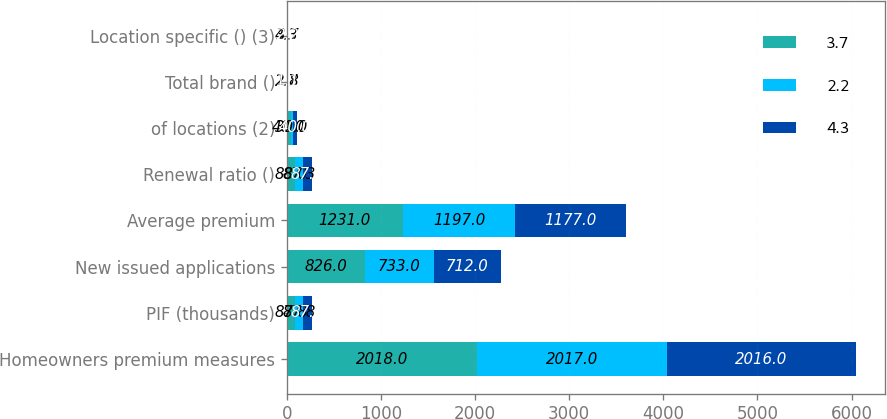Convert chart to OTSL. <chart><loc_0><loc_0><loc_500><loc_500><stacked_bar_chart><ecel><fcel>Homeowners premium measures<fcel>PIF (thousands)<fcel>New issued applications<fcel>Average premium<fcel>Renewal ratio ()<fcel>of locations (2)<fcel>Total brand ()<fcel>Location specific () (3)<nl><fcel>3.7<fcel>2018<fcel>87.8<fcel>826<fcel>1231<fcel>88<fcel>40<fcel>2.7<fcel>4.3<nl><fcel>2.2<fcel>2017<fcel>87.8<fcel>733<fcel>1197<fcel>87.3<fcel>30<fcel>1.8<fcel>3.7<nl><fcel>4.3<fcel>2016<fcel>87.8<fcel>712<fcel>1177<fcel>87.8<fcel>40<fcel>1.1<fcel>2.2<nl></chart> 